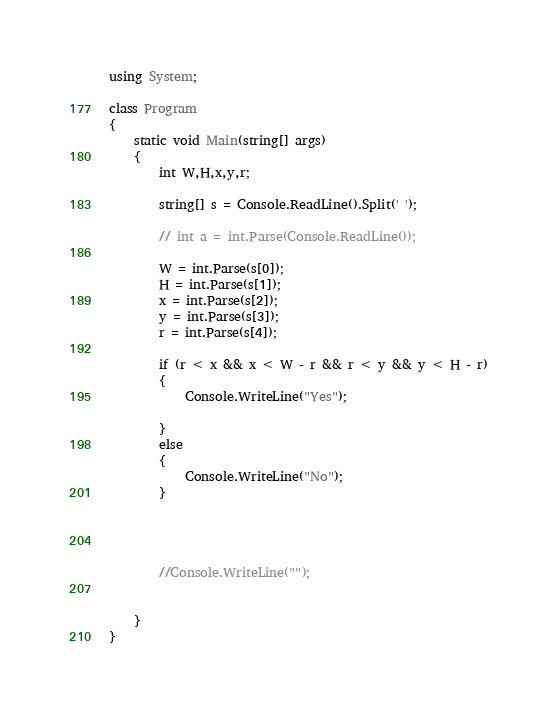<code> <loc_0><loc_0><loc_500><loc_500><_C#_>using System;

class Program
{
	static void Main(string[] args)
	{
        int W,H,x,y,r;

		string[] s = Console.ReadLine().Split(' ');

		// int a = int.Parse(Console.ReadLine());

		W = int.Parse(s[0]);
		H = int.Parse(s[1]);
        x = int.Parse(s[2]);
        y = int.Parse(s[3]);
        r = int.Parse(s[4]);

		if (r < x && x < W - r && r < y && y < H - r)
		{
			Console.WriteLine("Yes");

		}
		else
		{
			Console.WriteLine("No");
		}




		//Console.WriteLine("");


	}
}</code> 